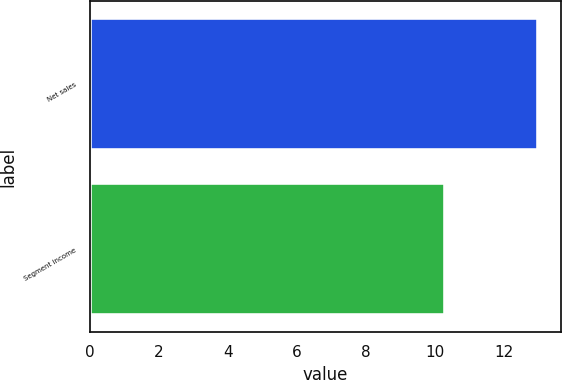Convert chart. <chart><loc_0><loc_0><loc_500><loc_500><bar_chart><fcel>Net sales<fcel>Segment income<nl><fcel>13<fcel>10.3<nl></chart> 